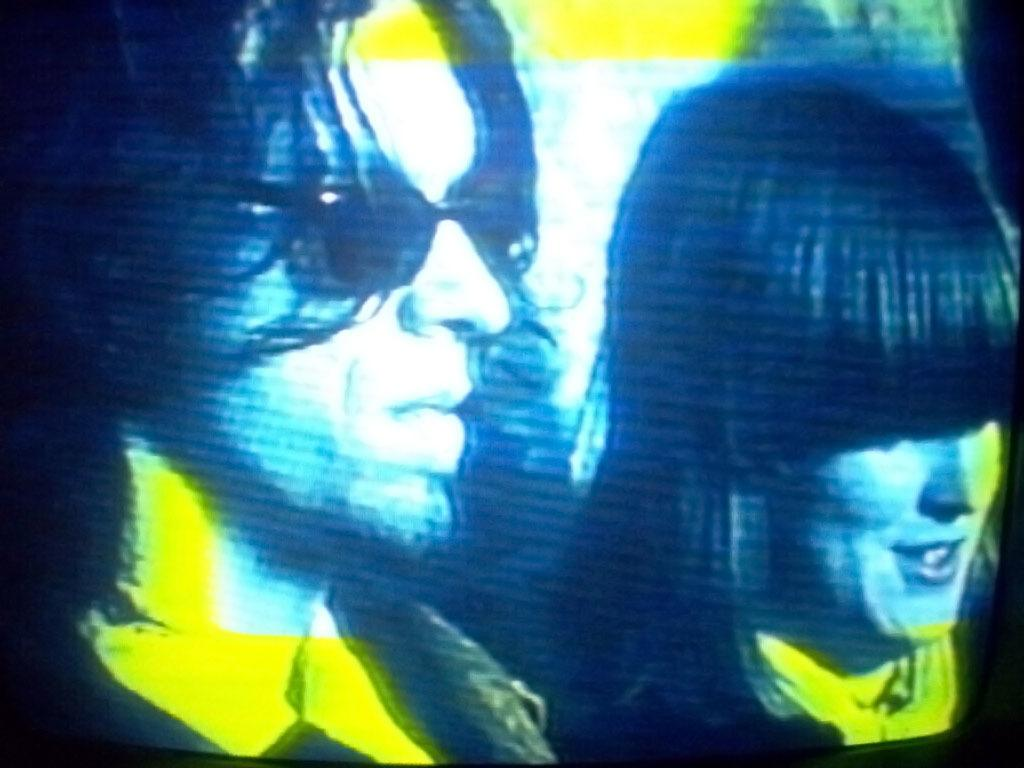What is the main object in the image? There is a screen in the image. What can be seen on the screen? There are two people on the screen. What type of grip does the house have in the image? There is no house present in the image, only a screen with two people. 